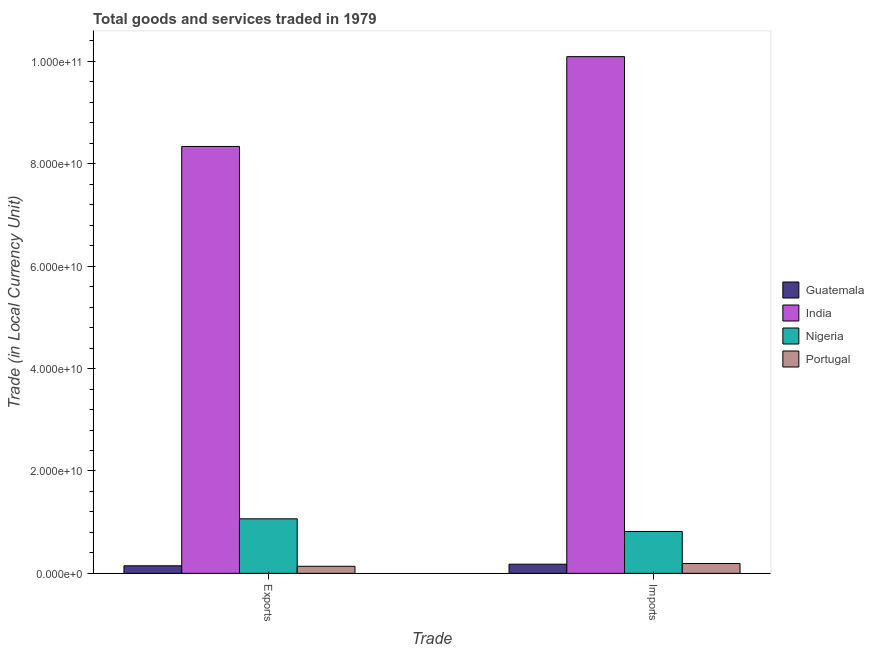How many groups of bars are there?
Your answer should be very brief. 2. Are the number of bars per tick equal to the number of legend labels?
Your response must be concise. Yes. How many bars are there on the 1st tick from the right?
Ensure brevity in your answer.  4. What is the label of the 1st group of bars from the left?
Give a very brief answer. Exports. What is the export of goods and services in Nigeria?
Provide a short and direct response. 1.06e+1. Across all countries, what is the maximum export of goods and services?
Your answer should be compact. 8.34e+1. Across all countries, what is the minimum export of goods and services?
Keep it short and to the point. 1.38e+09. In which country was the imports of goods and services minimum?
Offer a terse response. Guatemala. What is the total export of goods and services in the graph?
Ensure brevity in your answer.  9.69e+1. What is the difference between the imports of goods and services in Nigeria and that in India?
Make the answer very short. -9.28e+1. What is the difference between the export of goods and services in Portugal and the imports of goods and services in Nigeria?
Your response must be concise. -6.80e+09. What is the average imports of goods and services per country?
Provide a short and direct response. 2.82e+1. What is the difference between the export of goods and services and imports of goods and services in Nigeria?
Provide a succinct answer. 2.47e+09. In how many countries, is the imports of goods and services greater than 84000000000 LCU?
Your answer should be very brief. 1. What is the ratio of the export of goods and services in Portugal to that in Nigeria?
Make the answer very short. 0.13. In how many countries, is the export of goods and services greater than the average export of goods and services taken over all countries?
Give a very brief answer. 1. What does the 4th bar from the left in Imports represents?
Your answer should be compact. Portugal. What does the 4th bar from the right in Imports represents?
Make the answer very short. Guatemala. Does the graph contain any zero values?
Offer a terse response. No. Where does the legend appear in the graph?
Your response must be concise. Center right. How many legend labels are there?
Your answer should be very brief. 4. What is the title of the graph?
Offer a terse response. Total goods and services traded in 1979. Does "St. Kitts and Nevis" appear as one of the legend labels in the graph?
Your answer should be compact. No. What is the label or title of the X-axis?
Offer a terse response. Trade. What is the label or title of the Y-axis?
Provide a short and direct response. Trade (in Local Currency Unit). What is the Trade (in Local Currency Unit) in Guatemala in Exports?
Your answer should be very brief. 1.47e+09. What is the Trade (in Local Currency Unit) in India in Exports?
Ensure brevity in your answer.  8.34e+1. What is the Trade (in Local Currency Unit) in Nigeria in Exports?
Keep it short and to the point. 1.06e+1. What is the Trade (in Local Currency Unit) of Portugal in Exports?
Your answer should be very brief. 1.38e+09. What is the Trade (in Local Currency Unit) of Guatemala in Imports?
Your answer should be compact. 1.78e+09. What is the Trade (in Local Currency Unit) in India in Imports?
Offer a very short reply. 1.01e+11. What is the Trade (in Local Currency Unit) in Nigeria in Imports?
Give a very brief answer. 8.18e+09. What is the Trade (in Local Currency Unit) in Portugal in Imports?
Your answer should be very brief. 1.92e+09. Across all Trade, what is the maximum Trade (in Local Currency Unit) of Guatemala?
Ensure brevity in your answer.  1.78e+09. Across all Trade, what is the maximum Trade (in Local Currency Unit) of India?
Offer a terse response. 1.01e+11. Across all Trade, what is the maximum Trade (in Local Currency Unit) in Nigeria?
Your response must be concise. 1.06e+1. Across all Trade, what is the maximum Trade (in Local Currency Unit) in Portugal?
Your answer should be very brief. 1.92e+09. Across all Trade, what is the minimum Trade (in Local Currency Unit) of Guatemala?
Offer a very short reply. 1.47e+09. Across all Trade, what is the minimum Trade (in Local Currency Unit) of India?
Make the answer very short. 8.34e+1. Across all Trade, what is the minimum Trade (in Local Currency Unit) in Nigeria?
Offer a very short reply. 8.18e+09. Across all Trade, what is the minimum Trade (in Local Currency Unit) in Portugal?
Keep it short and to the point. 1.38e+09. What is the total Trade (in Local Currency Unit) in Guatemala in the graph?
Your answer should be very brief. 3.26e+09. What is the total Trade (in Local Currency Unit) of India in the graph?
Ensure brevity in your answer.  1.84e+11. What is the total Trade (in Local Currency Unit) of Nigeria in the graph?
Ensure brevity in your answer.  1.88e+1. What is the total Trade (in Local Currency Unit) of Portugal in the graph?
Keep it short and to the point. 3.30e+09. What is the difference between the Trade (in Local Currency Unit) of Guatemala in Exports and that in Imports?
Make the answer very short. -3.11e+08. What is the difference between the Trade (in Local Currency Unit) in India in Exports and that in Imports?
Your response must be concise. -1.75e+1. What is the difference between the Trade (in Local Currency Unit) of Nigeria in Exports and that in Imports?
Give a very brief answer. 2.47e+09. What is the difference between the Trade (in Local Currency Unit) in Portugal in Exports and that in Imports?
Make the answer very short. -5.42e+08. What is the difference between the Trade (in Local Currency Unit) of Guatemala in Exports and the Trade (in Local Currency Unit) of India in Imports?
Offer a very short reply. -9.95e+1. What is the difference between the Trade (in Local Currency Unit) in Guatemala in Exports and the Trade (in Local Currency Unit) in Nigeria in Imports?
Provide a succinct answer. -6.71e+09. What is the difference between the Trade (in Local Currency Unit) of Guatemala in Exports and the Trade (in Local Currency Unit) of Portugal in Imports?
Your response must be concise. -4.45e+08. What is the difference between the Trade (in Local Currency Unit) in India in Exports and the Trade (in Local Currency Unit) in Nigeria in Imports?
Keep it short and to the point. 7.52e+1. What is the difference between the Trade (in Local Currency Unit) in India in Exports and the Trade (in Local Currency Unit) in Portugal in Imports?
Offer a terse response. 8.15e+1. What is the difference between the Trade (in Local Currency Unit) in Nigeria in Exports and the Trade (in Local Currency Unit) in Portugal in Imports?
Ensure brevity in your answer.  8.73e+09. What is the average Trade (in Local Currency Unit) in Guatemala per Trade?
Ensure brevity in your answer.  1.63e+09. What is the average Trade (in Local Currency Unit) in India per Trade?
Your answer should be compact. 9.22e+1. What is the average Trade (in Local Currency Unit) of Nigeria per Trade?
Provide a short and direct response. 9.41e+09. What is the average Trade (in Local Currency Unit) of Portugal per Trade?
Ensure brevity in your answer.  1.65e+09. What is the difference between the Trade (in Local Currency Unit) in Guatemala and Trade (in Local Currency Unit) in India in Exports?
Your response must be concise. -8.19e+1. What is the difference between the Trade (in Local Currency Unit) in Guatemala and Trade (in Local Currency Unit) in Nigeria in Exports?
Make the answer very short. -9.18e+09. What is the difference between the Trade (in Local Currency Unit) in Guatemala and Trade (in Local Currency Unit) in Portugal in Exports?
Keep it short and to the point. 9.67e+07. What is the difference between the Trade (in Local Currency Unit) in India and Trade (in Local Currency Unit) in Nigeria in Exports?
Offer a terse response. 7.28e+1. What is the difference between the Trade (in Local Currency Unit) of India and Trade (in Local Currency Unit) of Portugal in Exports?
Offer a very short reply. 8.20e+1. What is the difference between the Trade (in Local Currency Unit) of Nigeria and Trade (in Local Currency Unit) of Portugal in Exports?
Offer a terse response. 9.27e+09. What is the difference between the Trade (in Local Currency Unit) of Guatemala and Trade (in Local Currency Unit) of India in Imports?
Keep it short and to the point. -9.92e+1. What is the difference between the Trade (in Local Currency Unit) of Guatemala and Trade (in Local Currency Unit) of Nigeria in Imports?
Offer a terse response. -6.40e+09. What is the difference between the Trade (in Local Currency Unit) in Guatemala and Trade (in Local Currency Unit) in Portugal in Imports?
Keep it short and to the point. -1.34e+08. What is the difference between the Trade (in Local Currency Unit) in India and Trade (in Local Currency Unit) in Nigeria in Imports?
Your answer should be compact. 9.28e+1. What is the difference between the Trade (in Local Currency Unit) in India and Trade (in Local Currency Unit) in Portugal in Imports?
Your answer should be very brief. 9.90e+1. What is the difference between the Trade (in Local Currency Unit) in Nigeria and Trade (in Local Currency Unit) in Portugal in Imports?
Your answer should be very brief. 6.26e+09. What is the ratio of the Trade (in Local Currency Unit) of Guatemala in Exports to that in Imports?
Ensure brevity in your answer.  0.83. What is the ratio of the Trade (in Local Currency Unit) of India in Exports to that in Imports?
Make the answer very short. 0.83. What is the ratio of the Trade (in Local Currency Unit) of Nigeria in Exports to that in Imports?
Provide a short and direct response. 1.3. What is the ratio of the Trade (in Local Currency Unit) of Portugal in Exports to that in Imports?
Keep it short and to the point. 0.72. What is the difference between the highest and the second highest Trade (in Local Currency Unit) in Guatemala?
Ensure brevity in your answer.  3.11e+08. What is the difference between the highest and the second highest Trade (in Local Currency Unit) of India?
Provide a short and direct response. 1.75e+1. What is the difference between the highest and the second highest Trade (in Local Currency Unit) of Nigeria?
Keep it short and to the point. 2.47e+09. What is the difference between the highest and the second highest Trade (in Local Currency Unit) of Portugal?
Offer a terse response. 5.42e+08. What is the difference between the highest and the lowest Trade (in Local Currency Unit) of Guatemala?
Provide a short and direct response. 3.11e+08. What is the difference between the highest and the lowest Trade (in Local Currency Unit) of India?
Offer a terse response. 1.75e+1. What is the difference between the highest and the lowest Trade (in Local Currency Unit) of Nigeria?
Provide a short and direct response. 2.47e+09. What is the difference between the highest and the lowest Trade (in Local Currency Unit) of Portugal?
Your answer should be very brief. 5.42e+08. 